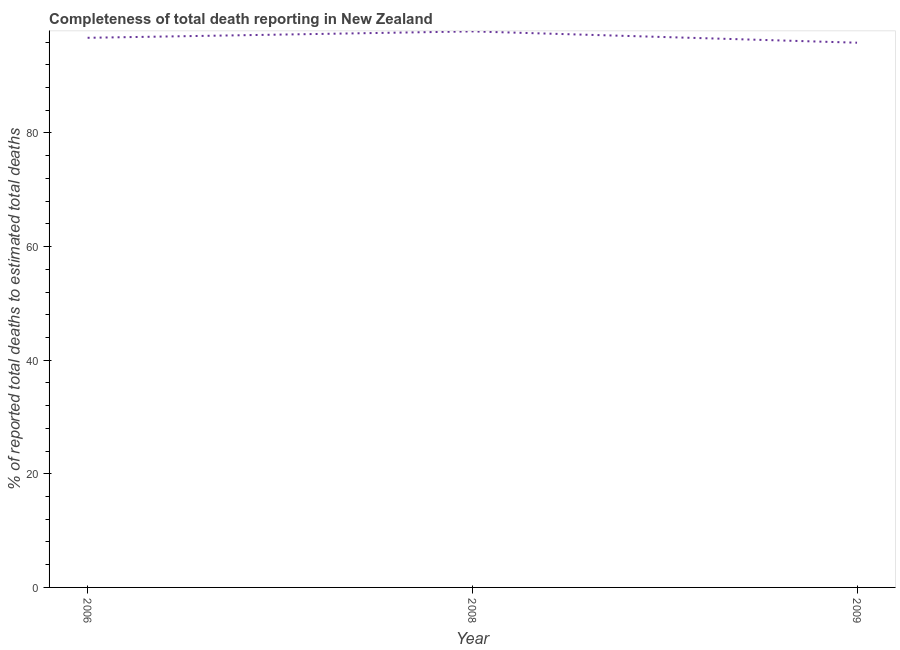What is the completeness of total death reports in 2009?
Offer a terse response. 95.89. Across all years, what is the maximum completeness of total death reports?
Your answer should be very brief. 97.88. Across all years, what is the minimum completeness of total death reports?
Make the answer very short. 95.89. In which year was the completeness of total death reports minimum?
Offer a terse response. 2009. What is the sum of the completeness of total death reports?
Your answer should be compact. 290.51. What is the difference between the completeness of total death reports in 2008 and 2009?
Keep it short and to the point. 1.99. What is the average completeness of total death reports per year?
Give a very brief answer. 96.84. What is the median completeness of total death reports?
Make the answer very short. 96.75. In how many years, is the completeness of total death reports greater than 84 %?
Make the answer very short. 3. What is the ratio of the completeness of total death reports in 2006 to that in 2008?
Offer a very short reply. 0.99. Is the completeness of total death reports in 2006 less than that in 2009?
Keep it short and to the point. No. What is the difference between the highest and the second highest completeness of total death reports?
Provide a short and direct response. 1.13. What is the difference between the highest and the lowest completeness of total death reports?
Keep it short and to the point. 1.99. How many lines are there?
Give a very brief answer. 1. How many years are there in the graph?
Your answer should be compact. 3. Does the graph contain any zero values?
Keep it short and to the point. No. What is the title of the graph?
Give a very brief answer. Completeness of total death reporting in New Zealand. What is the label or title of the Y-axis?
Ensure brevity in your answer.  % of reported total deaths to estimated total deaths. What is the % of reported total deaths to estimated total deaths of 2006?
Provide a succinct answer. 96.75. What is the % of reported total deaths to estimated total deaths of 2008?
Your answer should be compact. 97.88. What is the % of reported total deaths to estimated total deaths in 2009?
Give a very brief answer. 95.89. What is the difference between the % of reported total deaths to estimated total deaths in 2006 and 2008?
Keep it short and to the point. -1.13. What is the difference between the % of reported total deaths to estimated total deaths in 2006 and 2009?
Make the answer very short. 0.86. What is the difference between the % of reported total deaths to estimated total deaths in 2008 and 2009?
Your answer should be compact. 1.99. 